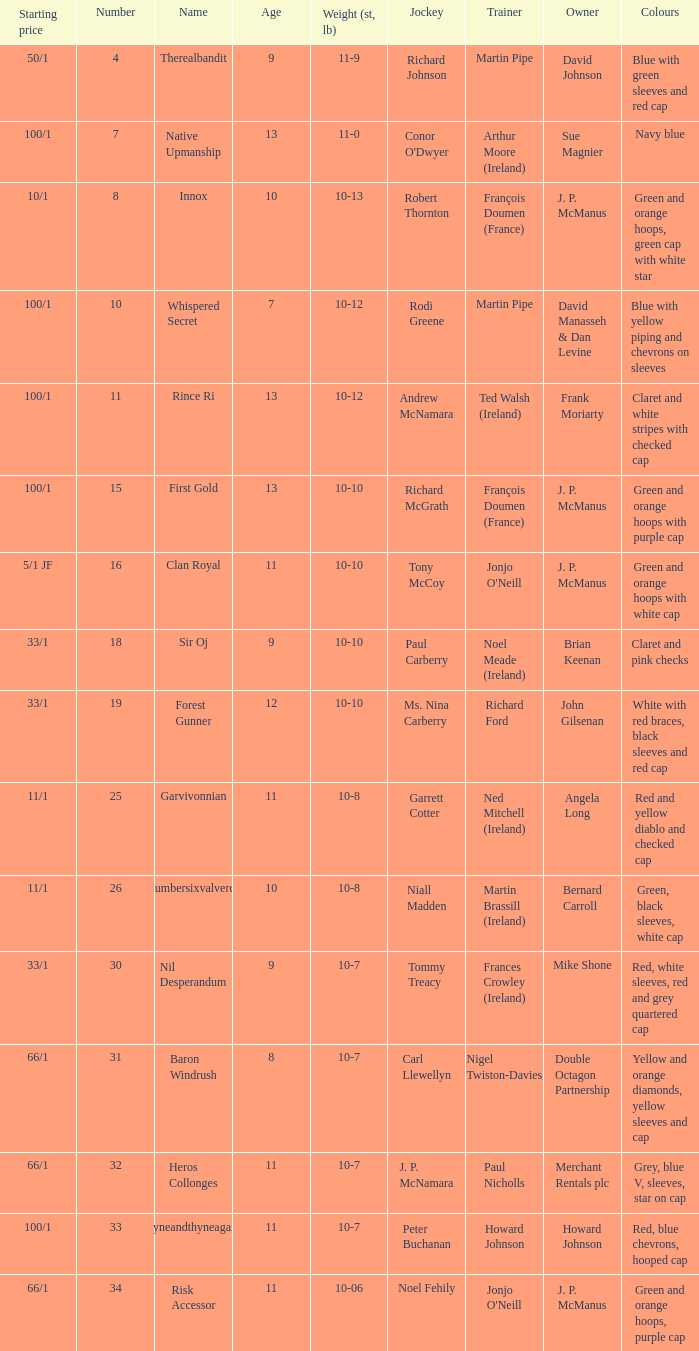How many age entries had a weight of 10-7 and an owner of Double Octagon Partnership? 1.0. 